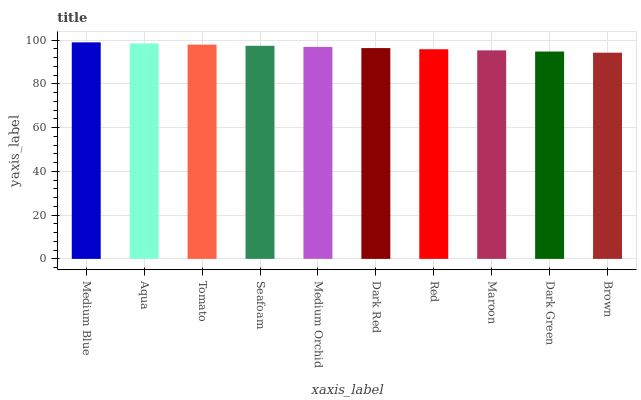Is Aqua the minimum?
Answer yes or no. No. Is Aqua the maximum?
Answer yes or no. No. Is Medium Blue greater than Aqua?
Answer yes or no. Yes. Is Aqua less than Medium Blue?
Answer yes or no. Yes. Is Aqua greater than Medium Blue?
Answer yes or no. No. Is Medium Blue less than Aqua?
Answer yes or no. No. Is Medium Orchid the high median?
Answer yes or no. Yes. Is Dark Red the low median?
Answer yes or no. Yes. Is Medium Blue the high median?
Answer yes or no. No. Is Medium Orchid the low median?
Answer yes or no. No. 